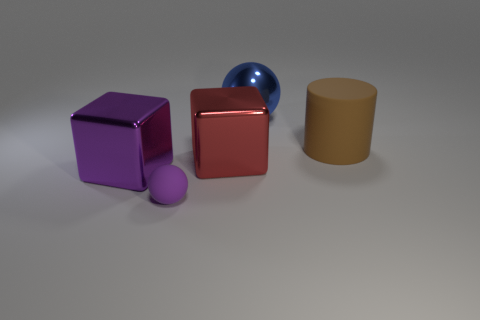Add 4 small purple things. How many objects exist? 9 Subtract all cylinders. How many objects are left? 4 Add 5 balls. How many balls are left? 7 Add 3 small purple spheres. How many small purple spheres exist? 4 Subtract 1 purple spheres. How many objects are left? 4 Subtract all brown matte objects. Subtract all big blue shiny objects. How many objects are left? 3 